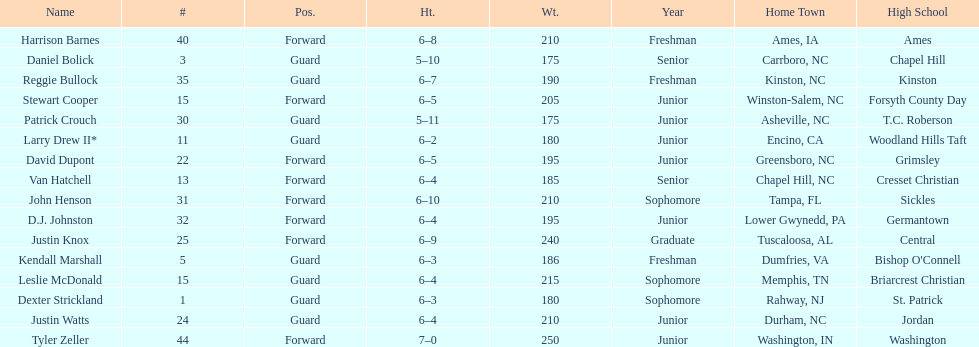How many players were more elevated than van hatchell? 7. 